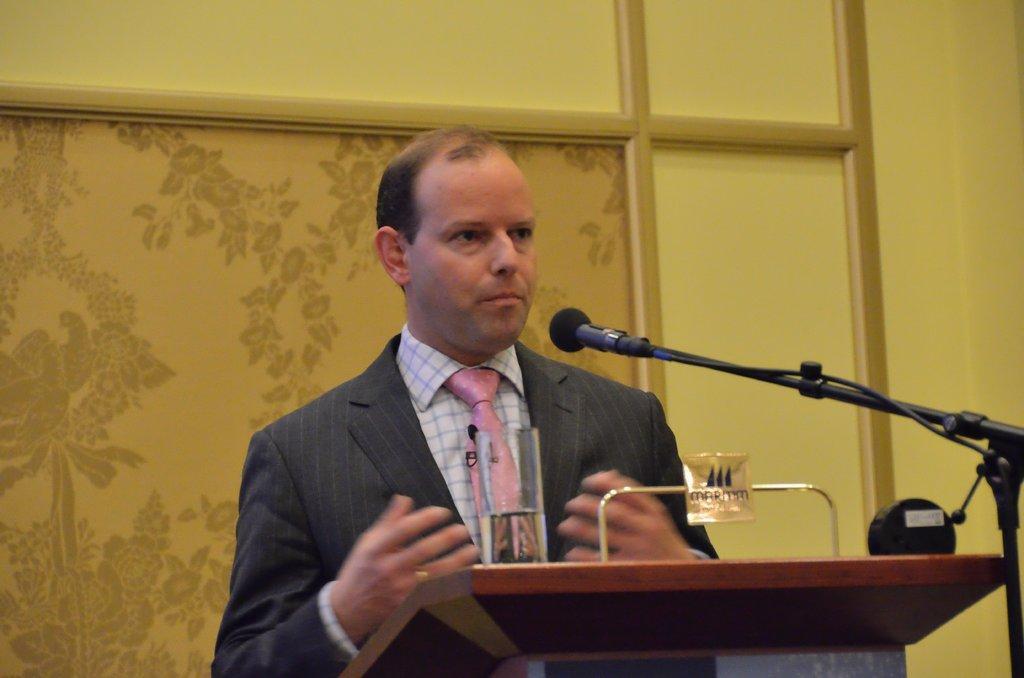Can you describe this image briefly? In this picture I see a podium in front and I see a mic on the tripod and I see a man who is standing in front of this podium and I see a glass. In the background I see the wall and I see the designs on it. 